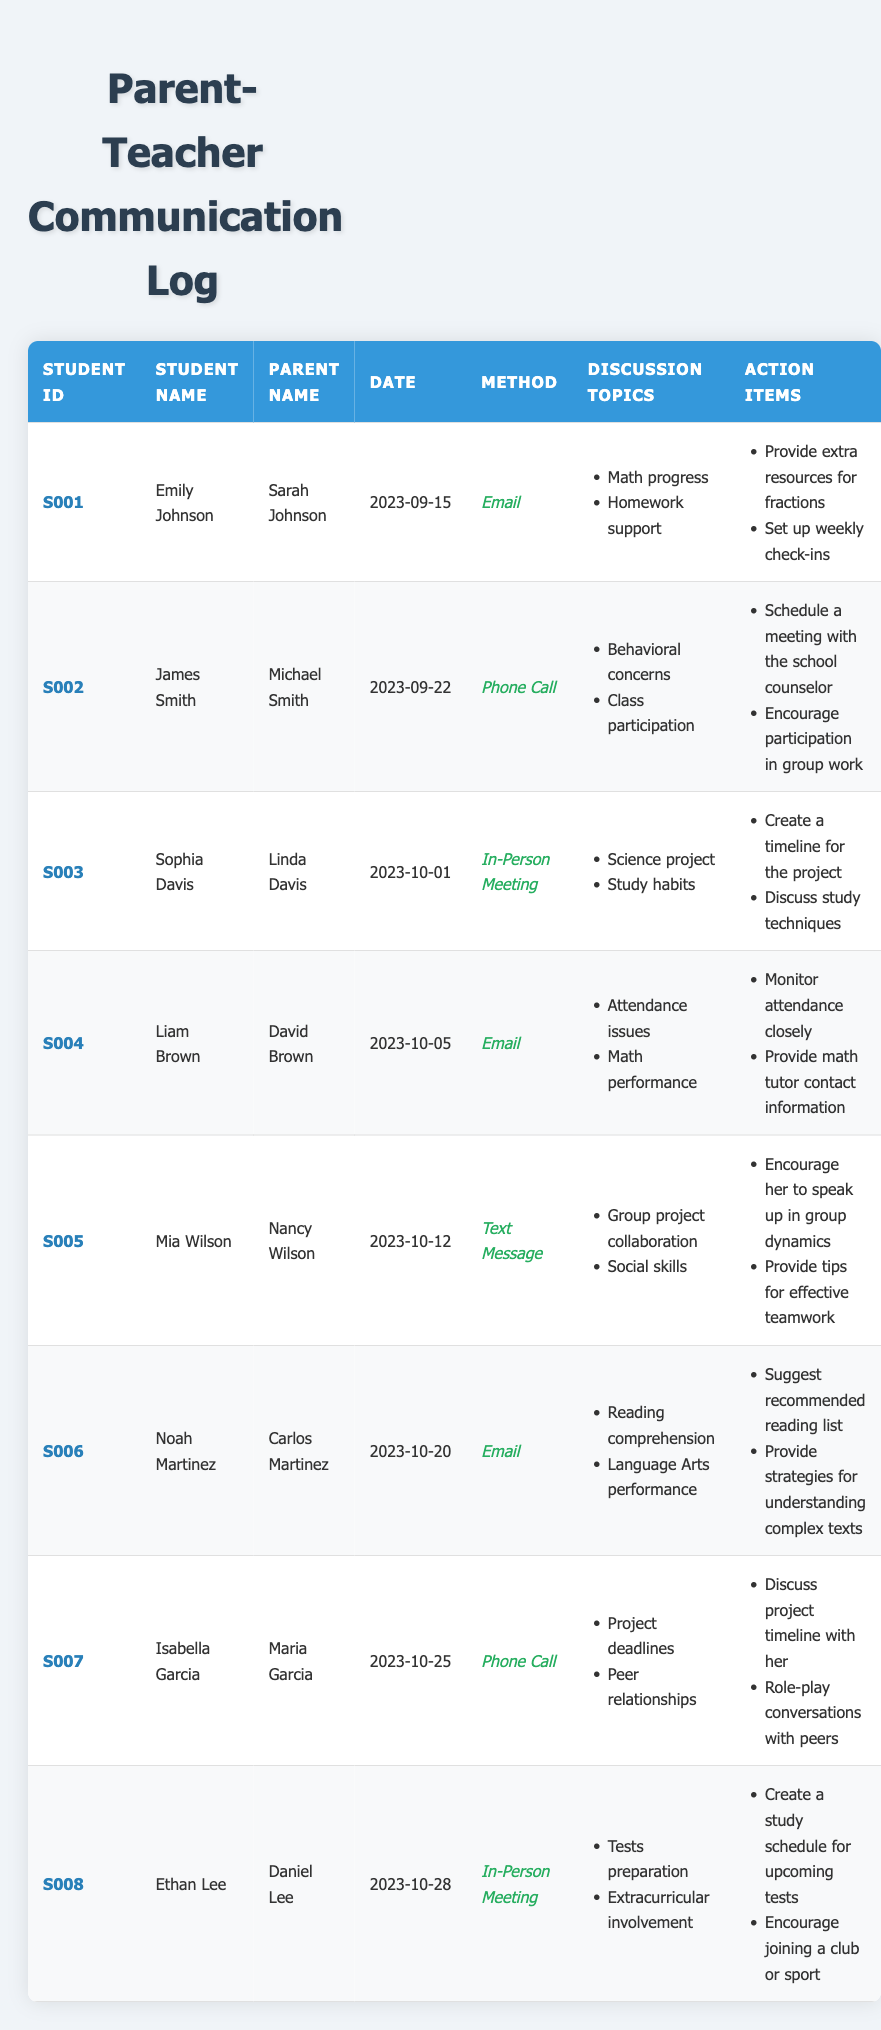What method was used to communicate with Mia Wilson's parent? In the table, the column for communication method shows "Text Message" for Mia Wilson's entry.
Answer: Text Message Which student had a communication regarding "Attendance issues"? Looking through the discussion topics, Liam Brown's entry lists "Attendance issues" as a topic of discussion on the date of October 5, 2023.
Answer: Liam Brown How many communication logs were documented via email? By counting the entries with "Email" in the communication method column, we find there are 4 such instances (Emily Johnson, Liam Brown, Noah Martinez).
Answer: 4 Did any communications focus on group project collaboration? Checking the discussion topics, Mia Wilson's communication on October 12, 2023, addresses "Group project collaboration," thus this statement is true.
Answer: Yes What was the action item discussed for James Smith's concerns? For James Smith, the action items included "Schedule a meeting with the school counselor" and "Encourage participation in group work," both of which pertain to his behavioral concerns.
Answer: Schedule a meeting with the school counselor Which student had the most recent communication log date? The latest date in the communication logs is October 28, 2023, noted for Ethan Lee. Therefore, he had the most recent communication.
Answer: Ethan Lee How many times were "study techniques" mentioned in discussion topics? In the provided logs, "study techniques" appears only once in Sophia Davis's entry on October 1, 2023, thus it is mentioned only once in total.
Answer: 1 What are the action items suggested for Noah Martinez? For Noah Martinez, the action items are "Suggest recommended reading list" and "Provide strategies for understanding complex texts," as indicated in his entry from October 20, 2023.
Answer: Suggest recommended reading list and provide strategies for understanding complex texts How do the action items for Emily Johnson differ from those for Isabella Garcia? Emily Johnson's action items are focused on providing extra resources and weekly check-ins, while Isabella Garcia's items involve discussing her project timeline and role-playing. This shows a difference in focus between resource provision and hands-on support.
Answer: Differing focus on resources vs. hands-on support 